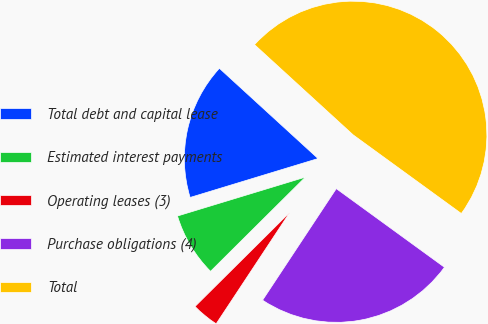<chart> <loc_0><loc_0><loc_500><loc_500><pie_chart><fcel>Total debt and capital lease<fcel>Estimated interest payments<fcel>Operating leases (3)<fcel>Purchase obligations (4)<fcel>Total<nl><fcel>16.49%<fcel>7.75%<fcel>3.26%<fcel>24.29%<fcel>48.22%<nl></chart> 